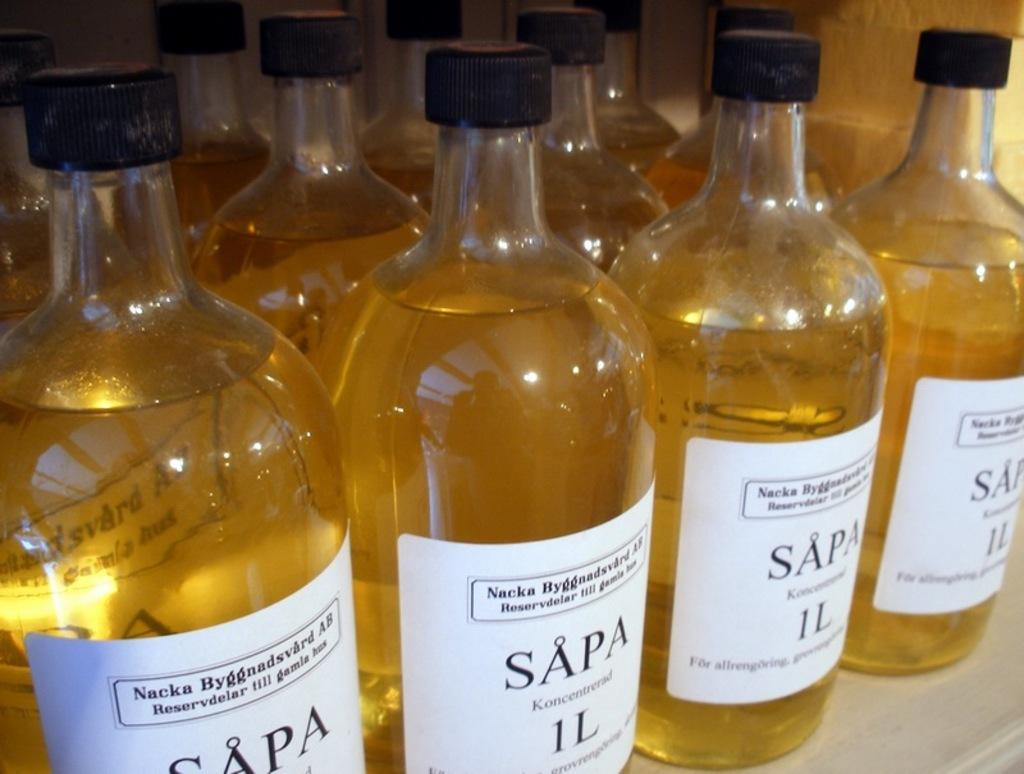<image>
Share a concise interpretation of the image provided. shelf full of bottles of sapa koncentrerad 1L 